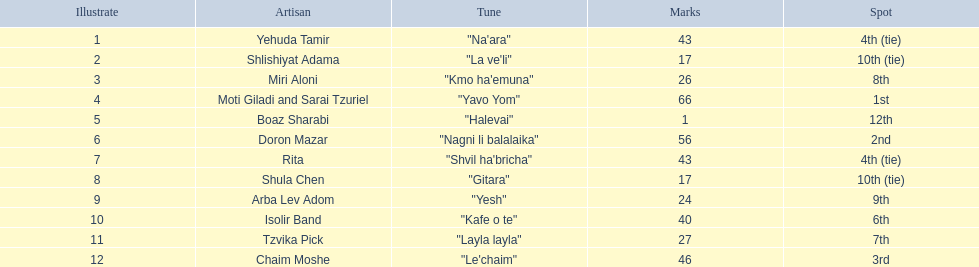What are the points in the competition? 43, 17, 26, 66, 1, 56, 43, 17, 24, 40, 27, 46. What is the lowest points? 1. What artist received these points? Boaz Sharabi. 